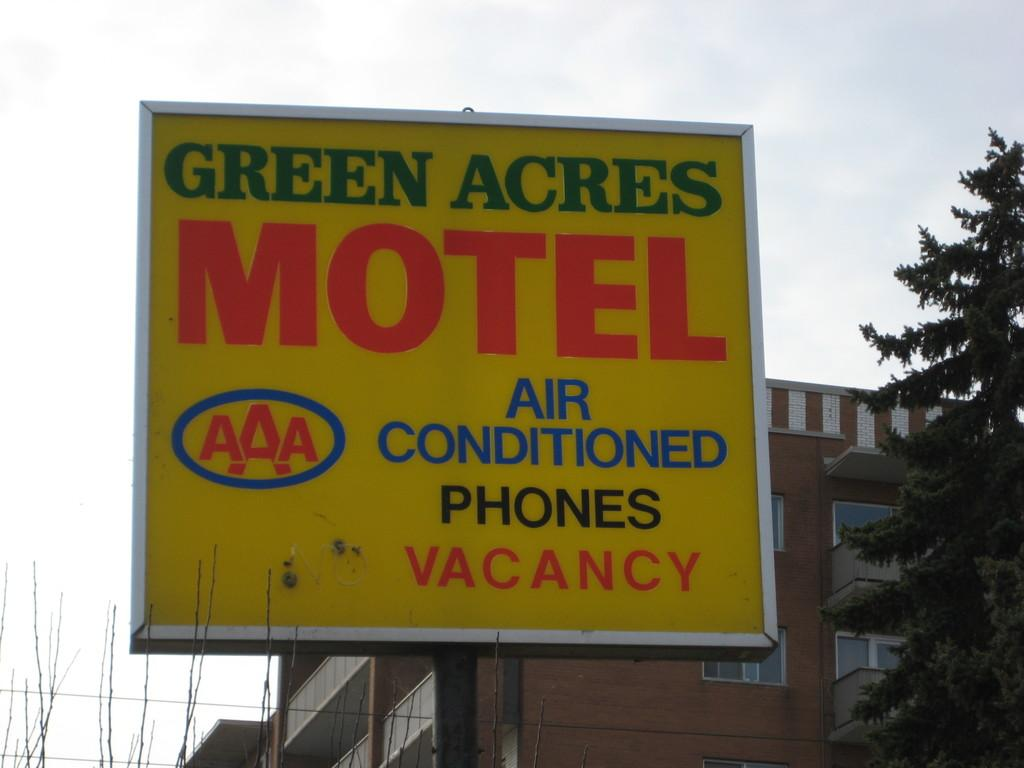<image>
Present a compact description of the photo's key features. The Green Acres Motel advertises its air conditioning and phones. 